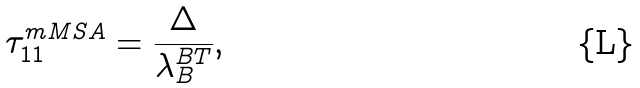Convert formula to latex. <formula><loc_0><loc_0><loc_500><loc_500>\tau _ { 1 1 } ^ { m M S A } = \frac { \Delta } { \lambda _ { B } ^ { B T } } ,</formula> 